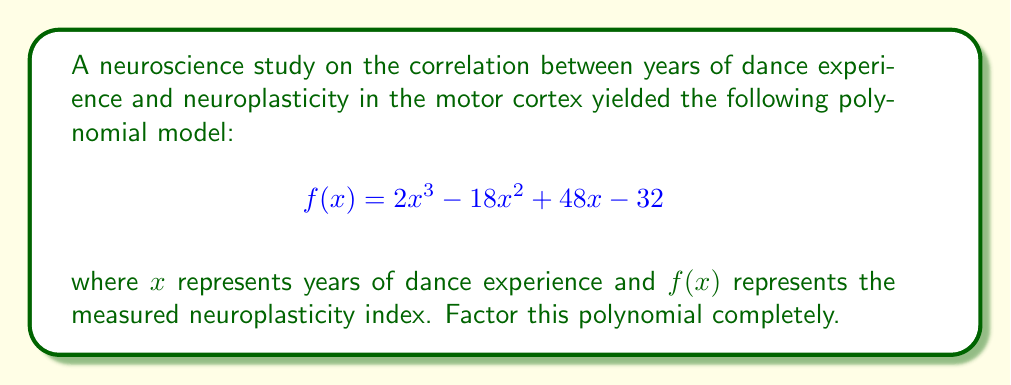Teach me how to tackle this problem. To factor this polynomial, we'll follow these steps:

1) First, let's check if there's a common factor:
   $2x^3 - 18x^2 + 48x - 32$
   There's no common factor for all terms.

2) Next, let's try the rational root theorem. The possible rational roots are the factors of the constant term (32): ±1, ±2, ±4, ±8, ±16, ±32.

3) Testing these values, we find that $f(2) = 0$. So $(x-2)$ is a factor.

4) Divide the polynomial by $(x-2)$ using polynomial long division:

   $$\frac{2x^3 - 18x^2 + 48x - 32}{x-2} = 2x^2 - 14x + 20$$

5) The quotient $2x^2 - 14x + 20$ is a quadratic that we can factor:

   $2x^2 - 14x + 20 = 2(x^2 - 7x + 10)$
   $= 2(x - 2)(x - 5)$

6) Therefore, the complete factorization is:

   $f(x) = 2x^3 - 18x^2 + 48x - 32$
   $= 2(x - 2)(x^2 - 7x + 10)$
   $= 2(x - 2)(x - 2)(x - 5)$
   $= 2(x - 2)^2(x - 5)$

This factorization suggests that the neuroplasticity index has critical points at 2 and 5 years of dance experience, with 2 years being a double root, indicating a possible inflection point in the relationship between dance experience and neuroplasticity.
Answer: $2(x - 2)^2(x - 5)$ 